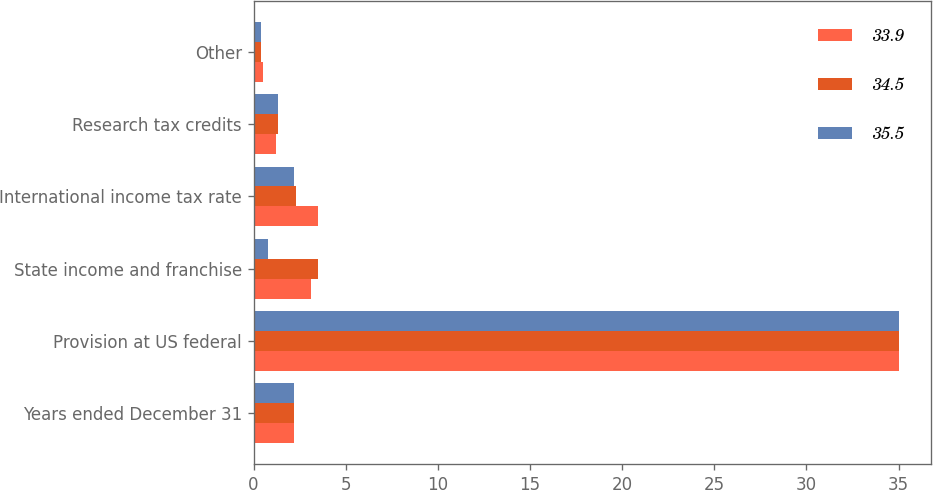Convert chart to OTSL. <chart><loc_0><loc_0><loc_500><loc_500><stacked_bar_chart><ecel><fcel>Years ended December 31<fcel>Provision at US federal<fcel>State income and franchise<fcel>International income tax rate<fcel>Research tax credits<fcel>Other<nl><fcel>33.9<fcel>2.2<fcel>35<fcel>3.1<fcel>3.5<fcel>1.2<fcel>0.5<nl><fcel>34.5<fcel>2.2<fcel>35<fcel>3.5<fcel>2.3<fcel>1.3<fcel>0.4<nl><fcel>35.5<fcel>2.2<fcel>35<fcel>0.8<fcel>2.2<fcel>1.3<fcel>0.4<nl></chart> 